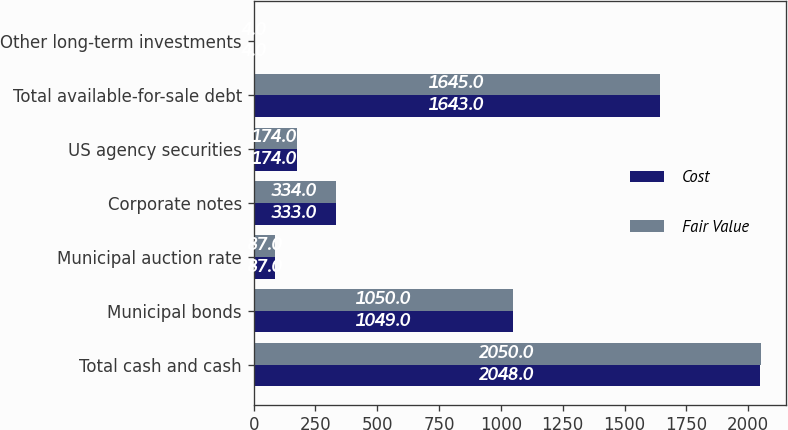Convert chart to OTSL. <chart><loc_0><loc_0><loc_500><loc_500><stacked_bar_chart><ecel><fcel>Total cash and cash<fcel>Municipal bonds<fcel>Municipal auction rate<fcel>Corporate notes<fcel>US agency securities<fcel>Total available-for-sale debt<fcel>Other long-term investments<nl><fcel>Cost<fcel>2048<fcel>1049<fcel>87<fcel>333<fcel>174<fcel>1643<fcel>4<nl><fcel>Fair Value<fcel>2050<fcel>1050<fcel>87<fcel>334<fcel>174<fcel>1645<fcel>4<nl></chart> 